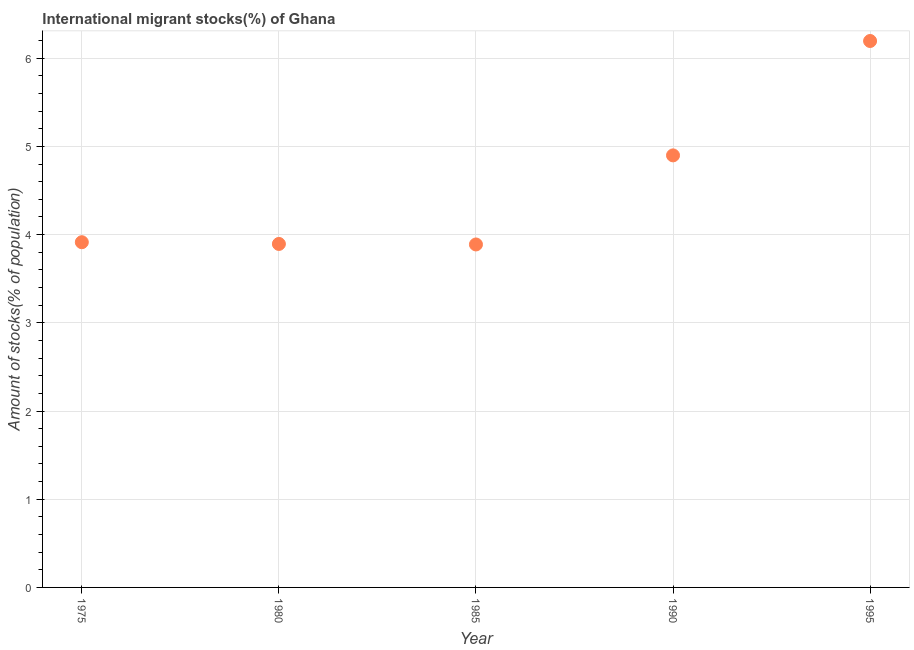What is the number of international migrant stocks in 1995?
Your answer should be very brief. 6.2. Across all years, what is the maximum number of international migrant stocks?
Make the answer very short. 6.2. Across all years, what is the minimum number of international migrant stocks?
Offer a very short reply. 3.89. In which year was the number of international migrant stocks maximum?
Offer a terse response. 1995. In which year was the number of international migrant stocks minimum?
Offer a very short reply. 1985. What is the sum of the number of international migrant stocks?
Make the answer very short. 22.79. What is the difference between the number of international migrant stocks in 1985 and 1995?
Offer a terse response. -2.31. What is the average number of international migrant stocks per year?
Make the answer very short. 4.56. What is the median number of international migrant stocks?
Give a very brief answer. 3.91. In how many years, is the number of international migrant stocks greater than 2 %?
Your response must be concise. 5. What is the ratio of the number of international migrant stocks in 1990 to that in 1995?
Your response must be concise. 0.79. Is the difference between the number of international migrant stocks in 1975 and 1995 greater than the difference between any two years?
Offer a very short reply. No. What is the difference between the highest and the second highest number of international migrant stocks?
Offer a very short reply. 1.3. Is the sum of the number of international migrant stocks in 1980 and 1995 greater than the maximum number of international migrant stocks across all years?
Make the answer very short. Yes. What is the difference between the highest and the lowest number of international migrant stocks?
Provide a succinct answer. 2.31. In how many years, is the number of international migrant stocks greater than the average number of international migrant stocks taken over all years?
Your answer should be compact. 2. Does the number of international migrant stocks monotonically increase over the years?
Ensure brevity in your answer.  No. How many dotlines are there?
Give a very brief answer. 1. How many years are there in the graph?
Offer a terse response. 5. Are the values on the major ticks of Y-axis written in scientific E-notation?
Your answer should be very brief. No. Does the graph contain grids?
Make the answer very short. Yes. What is the title of the graph?
Give a very brief answer. International migrant stocks(%) of Ghana. What is the label or title of the Y-axis?
Make the answer very short. Amount of stocks(% of population). What is the Amount of stocks(% of population) in 1975?
Keep it short and to the point. 3.91. What is the Amount of stocks(% of population) in 1980?
Give a very brief answer. 3.89. What is the Amount of stocks(% of population) in 1985?
Keep it short and to the point. 3.89. What is the Amount of stocks(% of population) in 1990?
Ensure brevity in your answer.  4.9. What is the Amount of stocks(% of population) in 1995?
Provide a short and direct response. 6.2. What is the difference between the Amount of stocks(% of population) in 1975 and 1980?
Make the answer very short. 0.02. What is the difference between the Amount of stocks(% of population) in 1975 and 1985?
Give a very brief answer. 0.03. What is the difference between the Amount of stocks(% of population) in 1975 and 1990?
Offer a very short reply. -0.98. What is the difference between the Amount of stocks(% of population) in 1975 and 1995?
Ensure brevity in your answer.  -2.28. What is the difference between the Amount of stocks(% of population) in 1980 and 1985?
Offer a terse response. 0.01. What is the difference between the Amount of stocks(% of population) in 1980 and 1990?
Your answer should be compact. -1. What is the difference between the Amount of stocks(% of population) in 1980 and 1995?
Make the answer very short. -2.3. What is the difference between the Amount of stocks(% of population) in 1985 and 1990?
Provide a succinct answer. -1.01. What is the difference between the Amount of stocks(% of population) in 1985 and 1995?
Give a very brief answer. -2.31. What is the difference between the Amount of stocks(% of population) in 1990 and 1995?
Provide a succinct answer. -1.3. What is the ratio of the Amount of stocks(% of population) in 1975 to that in 1980?
Offer a terse response. 1. What is the ratio of the Amount of stocks(% of population) in 1975 to that in 1990?
Give a very brief answer. 0.8. What is the ratio of the Amount of stocks(% of population) in 1975 to that in 1995?
Your answer should be compact. 0.63. What is the ratio of the Amount of stocks(% of population) in 1980 to that in 1990?
Offer a terse response. 0.8. What is the ratio of the Amount of stocks(% of population) in 1980 to that in 1995?
Give a very brief answer. 0.63. What is the ratio of the Amount of stocks(% of population) in 1985 to that in 1990?
Your answer should be compact. 0.79. What is the ratio of the Amount of stocks(% of population) in 1985 to that in 1995?
Your answer should be compact. 0.63. What is the ratio of the Amount of stocks(% of population) in 1990 to that in 1995?
Ensure brevity in your answer.  0.79. 